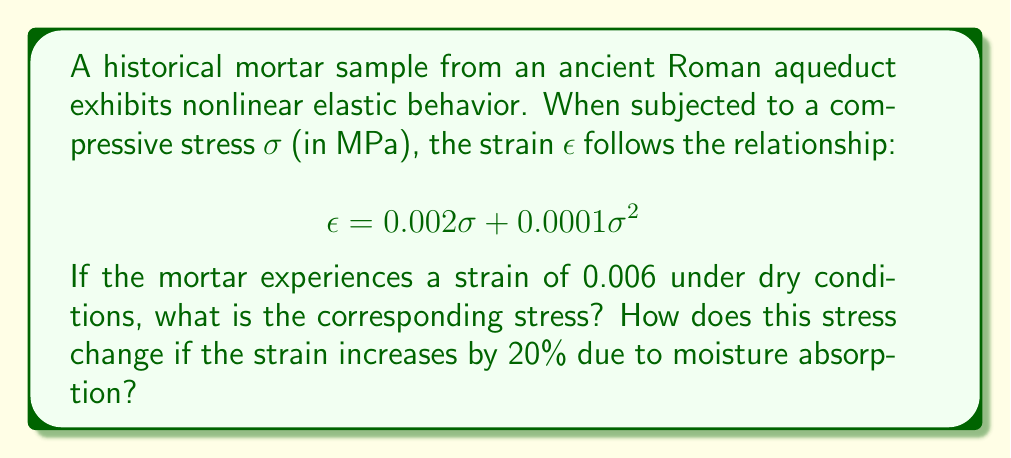Can you solve this math problem? 1. For the dry condition:
   We need to solve the quadratic equation:
   $$0.006 = 0.002\sigma + 0.0001\sigma^2$$

2. Rearrange the equation:
   $$0.0001\sigma^2 + 0.002\sigma - 0.006 = 0$$

3. Use the quadratic formula: $\sigma = \frac{-b \pm \sqrt{b^2 - 4ac}}{2a}$
   Where $a = 0.0001$, $b = 0.002$, and $c = -0.006$

4. Solve:
   $$\sigma = \frac{-0.002 \pm \sqrt{0.002^2 - 4(0.0001)(-0.006)}}{2(0.0001)}$$
   $$\sigma = \frac{-0.002 \pm \sqrt{0.000004 + 0.0024}}{0.0002}$$
   $$\sigma = \frac{-0.002 \pm \sqrt{0.002404}}{0.0002}$$
   $$\sigma = \frac{-0.002 \pm 0.049030}{0.0002}$$

5. Take the positive root:
   $$\sigma = \frac{-0.002 + 0.049030}{0.0002} = 235.15 \text{ MPa}$$

6. For the moist condition:
   New strain = $0.006 \times 1.20 = 0.0072$

7. Solve the new quadratic equation:
   $$0.0072 = 0.002\sigma + 0.0001\sigma^2$$

8. Following the same steps as before:
   $$\sigma = \frac{-0.002 \pm \sqrt{0.002^2 - 4(0.0001)(-0.0072)}}{2(0.0001)}$$
   $$\sigma = \frac{-0.002 \pm \sqrt{0.000004 + 0.00288}}{0.0002}$$
   $$\sigma = \frac{-0.002 \pm 0.053852}{0.0002}$$

9. Take the positive root:
   $$\sigma = \frac{-0.002 + 0.053852}{0.0002} = 259.26 \text{ MPa}$$

10. Calculate the change in stress:
    $$\Delta\sigma = 259.26 - 235.15 = 24.11 \text{ MPa}$$
Answer: Dry stress: 235.15 MPa; Stress increase: 24.11 MPa 